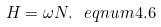<formula> <loc_0><loc_0><loc_500><loc_500>H = \omega N . \ e q n u m { 4 . 6 }</formula> 